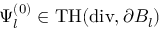Convert formula to latex. <formula><loc_0><loc_0><loc_500><loc_500>\Psi _ { l } ^ { ( 0 ) } \in T H ( d i v , \partial B _ { l } )</formula> 